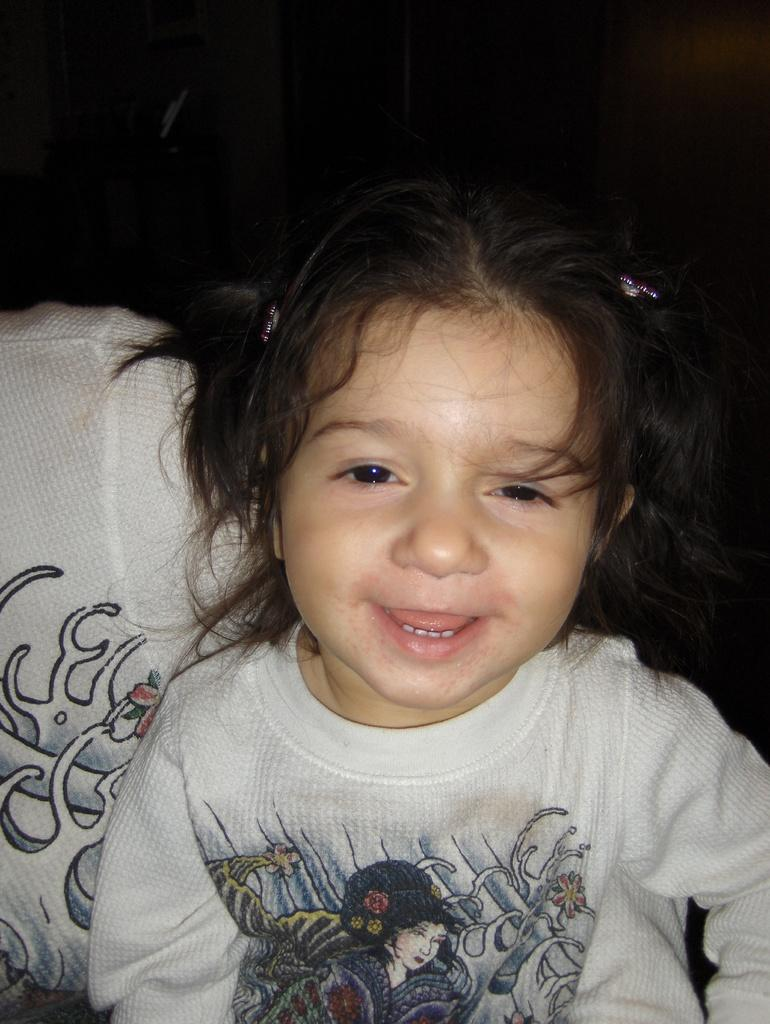Who is the main subject in the image? There is a girl in the image. What is the girl wearing? The girl is wearing a white t-shirt. What color is the background of the image? The background of the image is black in color. How far away is the bubble from the girl in the image? There is no bubble present in the image, so it cannot be determined how far away it might be from the girl. 